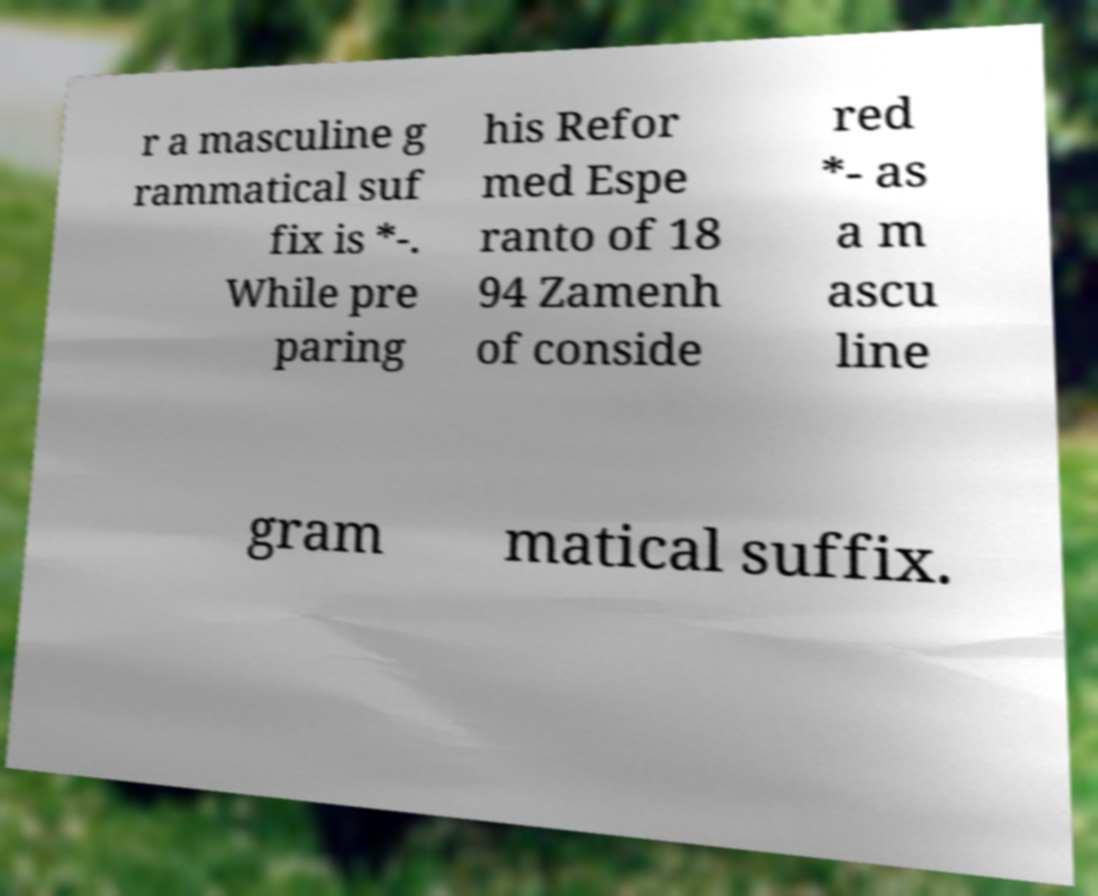What messages or text are displayed in this image? I need them in a readable, typed format. r a masculine g rammatical suf fix is *-. While pre paring his Refor med Espe ranto of 18 94 Zamenh of conside red *- as a m ascu line gram matical suffix. 